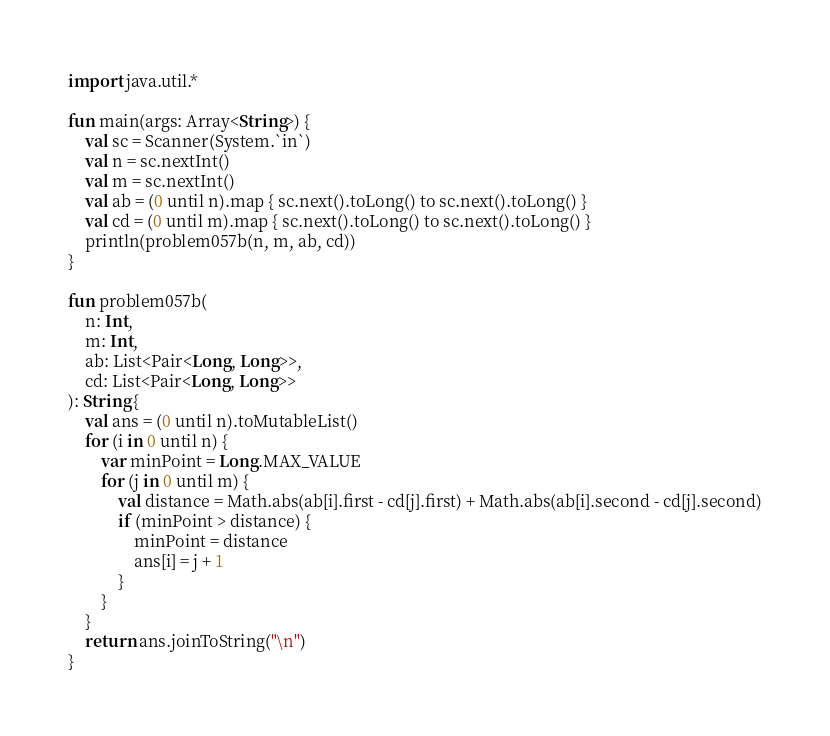Convert code to text. <code><loc_0><loc_0><loc_500><loc_500><_Kotlin_>import java.util.*

fun main(args: Array<String>) {
    val sc = Scanner(System.`in`)
    val n = sc.nextInt()
    val m = sc.nextInt()
    val ab = (0 until n).map { sc.next().toLong() to sc.next().toLong() }
    val cd = (0 until m).map { sc.next().toLong() to sc.next().toLong() }
    println(problem057b(n, m, ab, cd))
}

fun problem057b(
    n: Int,
    m: Int,
    ab: List<Pair<Long, Long>>,
    cd: List<Pair<Long, Long>>
): String {
    val ans = (0 until n).toMutableList()
    for (i in 0 until n) {
        var minPoint = Long.MAX_VALUE
        for (j in 0 until m) {
            val distance = Math.abs(ab[i].first - cd[j].first) + Math.abs(ab[i].second - cd[j].second)
            if (minPoint > distance) {
                minPoint = distance
                ans[i] = j + 1
            }
        }
    }
    return ans.joinToString("\n")
}</code> 